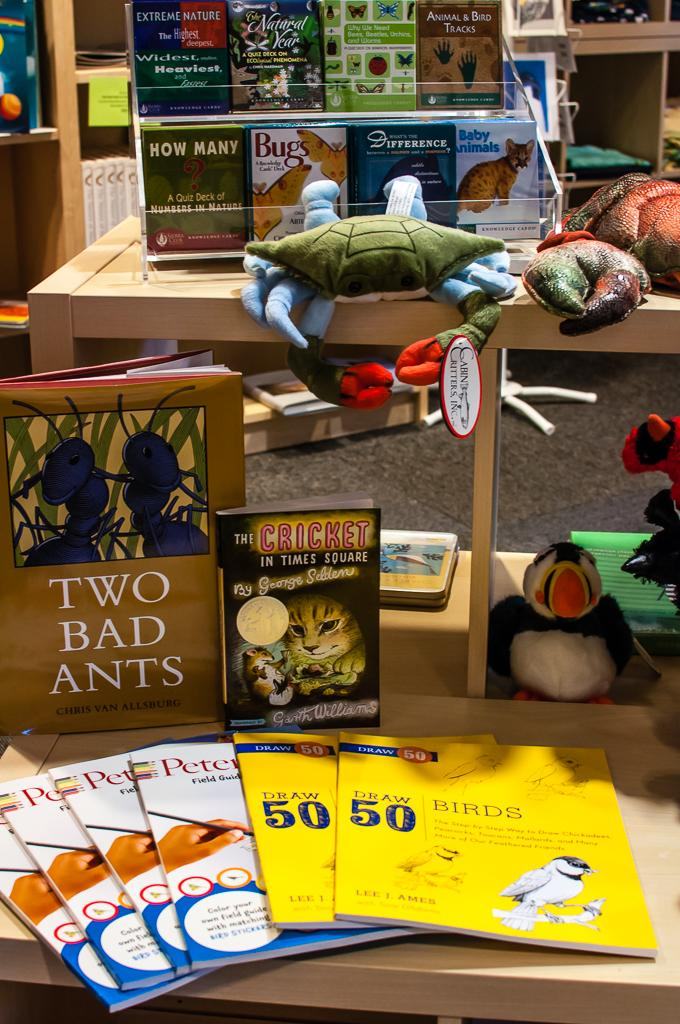<image>
Render a clear and concise summary of the photo. A selection of children's books, including Two Bad Ants by Chris van Allsburg. 